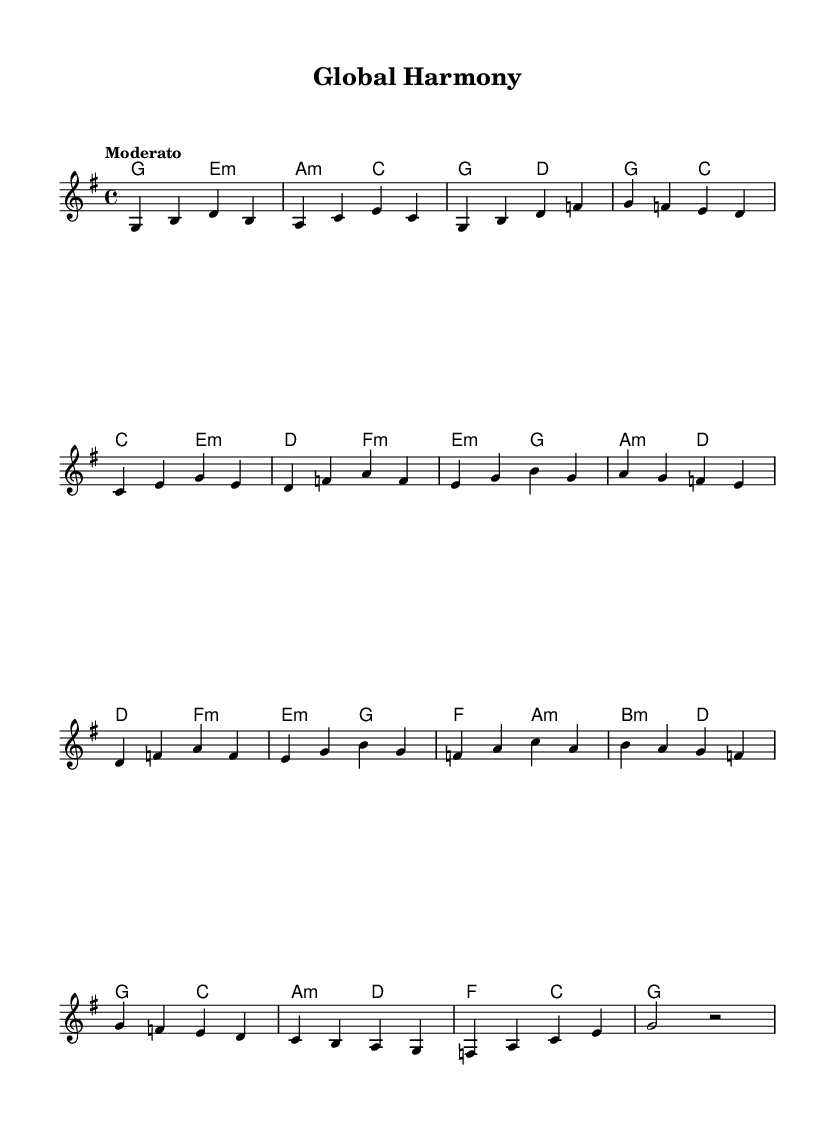What is the key signature of this music? The key signature is G major, which has one sharp (F#), indicated at the beginning of the staff.
Answer: G major What is the time signature of this piece? The time signature is 4/4, as indicated at the beginning, showing that there are four beats in each measure with a quarter note receiving one beat.
Answer: 4/4 What is the tempo marking for the piece? The tempo marking is "Moderato," which indicates a moderate pace, typically between 108 and 120 beats per minute.
Answer: Moderato How many measures are in the melody section? By counting the measures in the melody, there are a total of 16 measures present, as each grouping of notes delineates a measure.
Answer: 16 What is the first chord in the harmonies section? The first chord indicated in the harmonies section is G major, as specified at the start of the chord sequence.
Answer: G major Which musical form is being primarily represented in the piece? This piece showcases a simple A-B-A form common in folk music, where the first section (melody) is repeated after contrasting material.
Answer: A-B-A What characteristic of folk music does this piece exemplify? This piece exemplifies the accessibility and community aspect of folk music, as it features simple melodies and harmonies that can be easily performed and sung.
Answer: Accessibility 